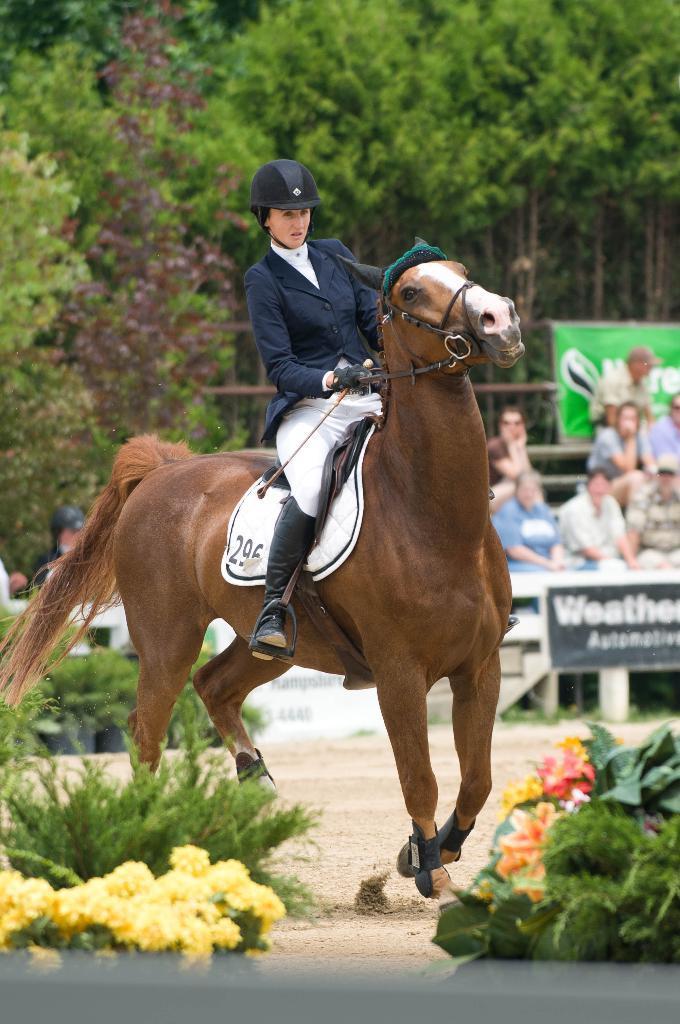In one or two sentences, can you explain what this image depicts? In this image I can see a woman riding a horse. In the background I can see number of people and number of trees. Here I can see few flowers. 